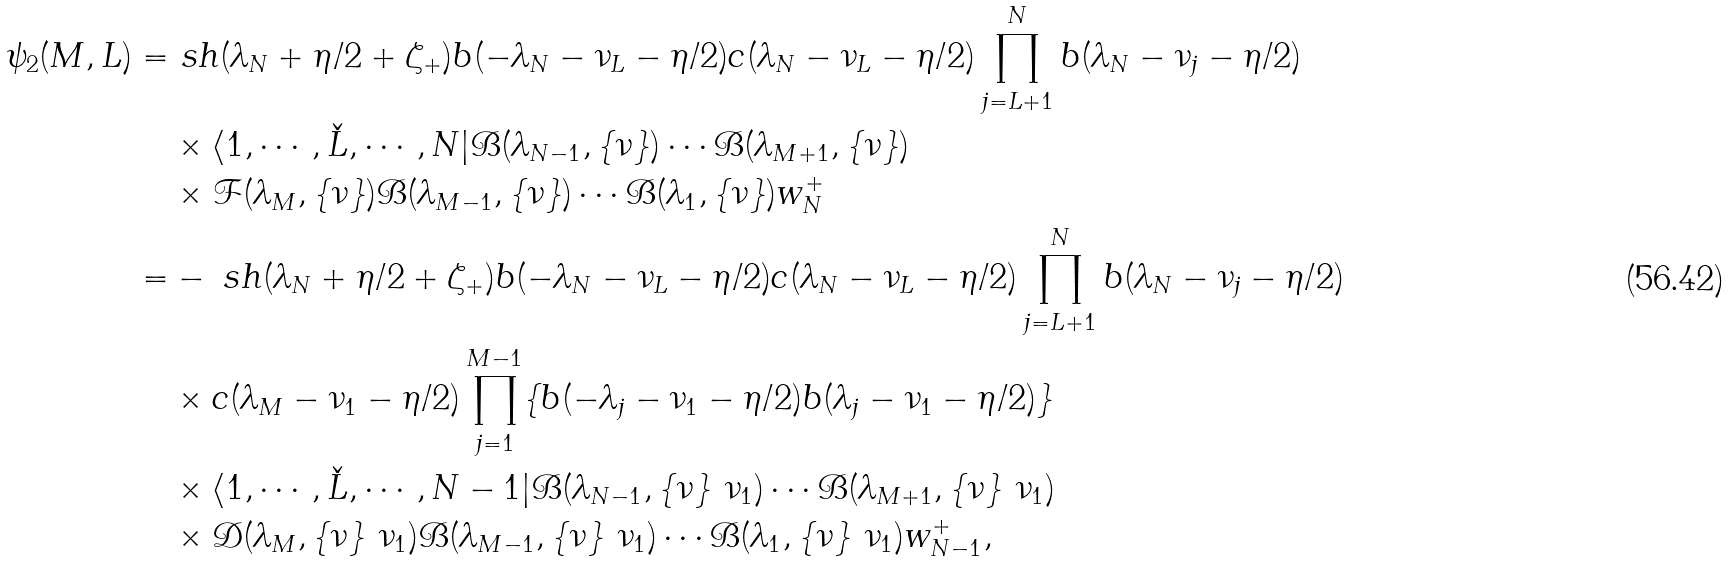Convert formula to latex. <formula><loc_0><loc_0><loc_500><loc_500>\psi _ { 2 } ( M , L ) = & \ s h ( \lambda _ { N } + \eta / 2 + \zeta _ { + } ) b ( - \lambda _ { N } - \nu _ { L } - \eta / 2 ) c ( \lambda _ { N } - \nu _ { L } - \eta / 2 ) \prod _ { j = L + 1 } ^ { N } b ( \lambda _ { N } - \nu _ { j } - \eta / 2 ) \\ & \times \langle 1 , \cdots , \check { L } , \cdots , N | \mathcal { B } ( \lambda _ { N - 1 } , \{ \nu \} ) \cdots \mathcal { B } ( \lambda _ { M + 1 } , \{ \nu \} ) \\ & \times \mathcal { F } ( \lambda _ { M } , \{ \nu \} ) \mathcal { B } ( \lambda _ { M - 1 } , \{ \nu \} ) \cdots \mathcal { B } ( \lambda _ { 1 } , \{ \nu \} ) w _ { N } ^ { + } \\ = & - \ s h ( \lambda _ { N } + \eta / 2 + \zeta _ { + } ) b ( - \lambda _ { N } - \nu _ { L } - \eta / 2 ) c ( \lambda _ { N } - \nu _ { L } - \eta / 2 ) \prod _ { j = L + 1 } ^ { N } b ( \lambda _ { N } - \nu _ { j } - \eta / 2 ) \\ & \times c ( \lambda _ { M } - \nu _ { 1 } - \eta / 2 ) \prod _ { j = 1 } ^ { M - 1 } \{ b ( - \lambda _ { j } - \nu _ { 1 } - \eta / 2 ) b ( \lambda _ { j } - \nu _ { 1 } - \eta / 2 ) \} \\ & \times \langle 1 , \cdots , \check { L } , \cdots , N - 1 | \mathcal { B } ( \lambda _ { N - 1 } , \{ \nu \} \ \nu _ { 1 } ) \cdots \mathcal { B } ( \lambda _ { M + 1 } , \{ \nu \} \ \nu _ { 1 } ) \\ & \times \mathcal { D } ( \lambda _ { M } , \{ \nu \} \ \nu _ { 1 } ) \mathcal { B } ( \lambda _ { M - 1 } , \{ \nu \} \ \nu _ { 1 } ) \cdots \mathcal { B } ( \lambda _ { 1 } , \{ \nu \} \ \nu _ { 1 } ) w _ { N - 1 } ^ { + } ,</formula> 